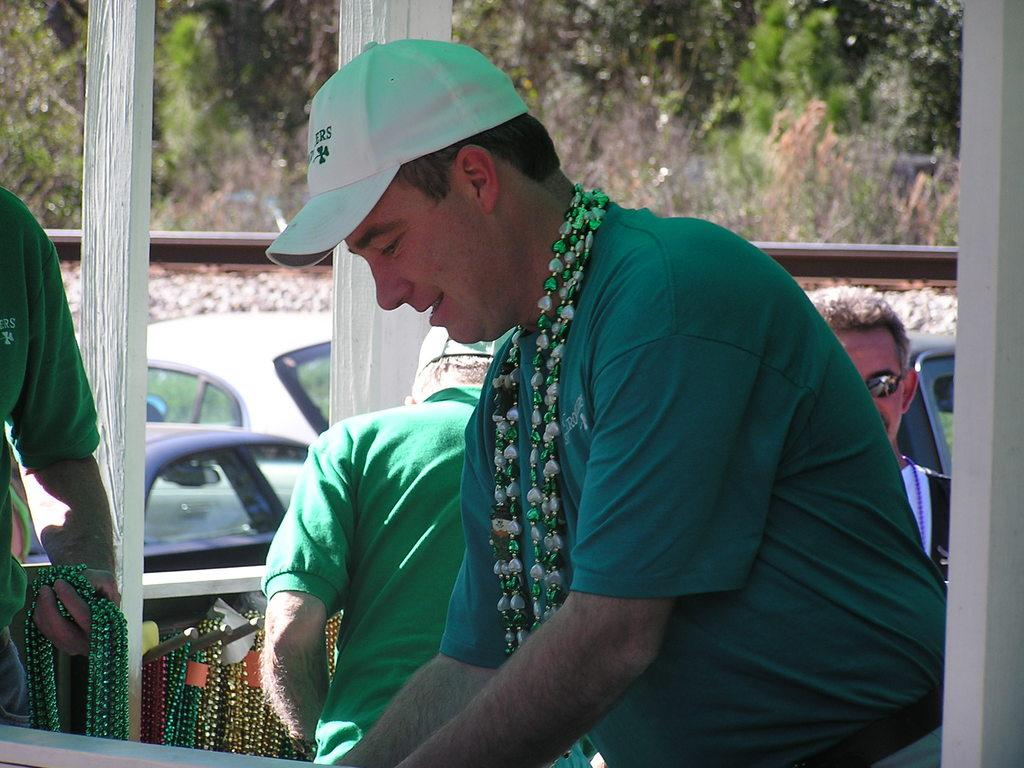What is the main subject of the image? There is a man in the middle of the image. What is the man wearing on his head? The man is wearing a cap. What can be seen in the background of the image? There are people, vehicles, poles, trees, and other objects visible in the background of the image. What type of crime is being committed in the image? There is no crime being committed in the image; it simply features a man wearing a cap and various objects in the background. What key is used to unlock the door in the image? There is no door or key present in the image. 